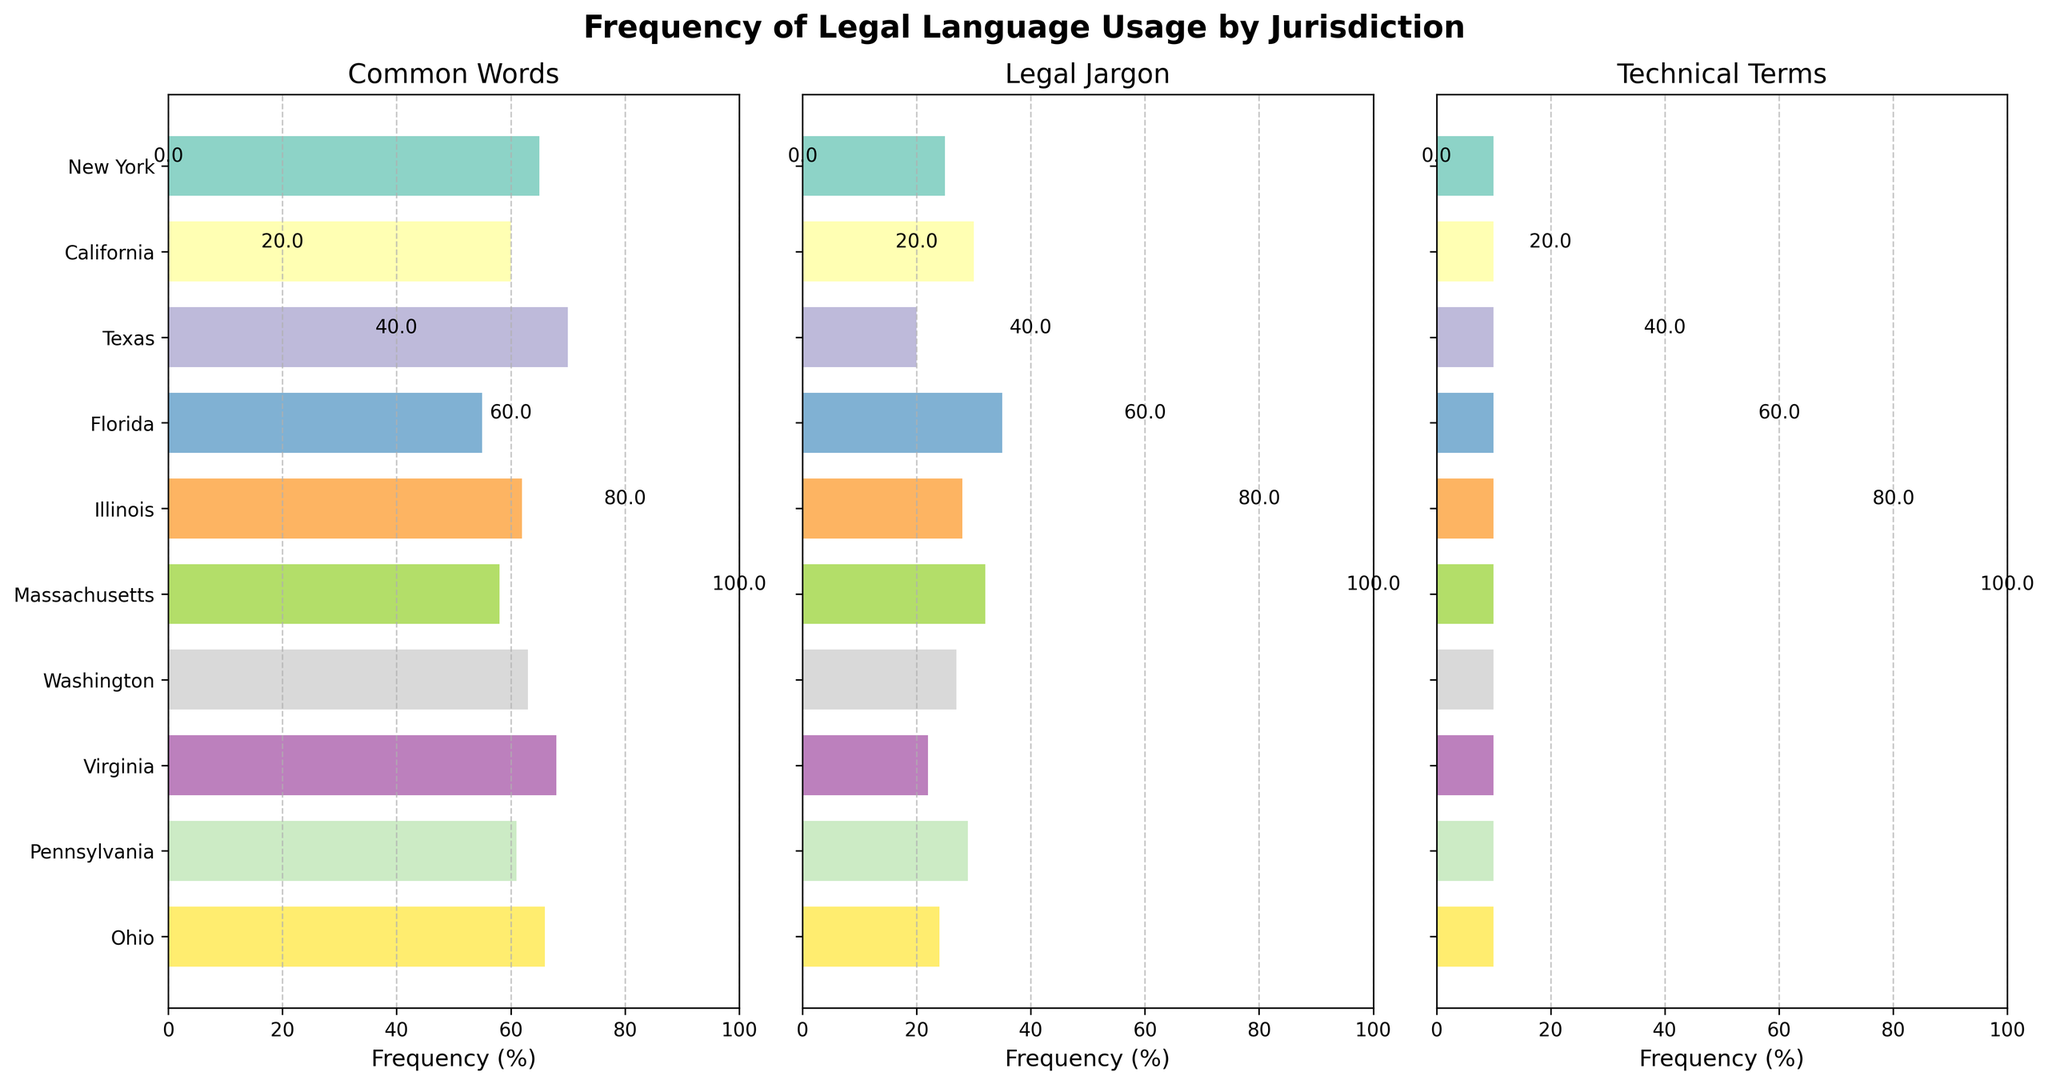Which jurisdiction has the highest frequency of common words? By looking at the "Common Words" subplot, we can see that Texas has the highest frequency bar for common words.
Answer: Texas Which jurisdiction has the lowest frequency of legal jargon? Observing the "Legal Jargon" subplot, we notice that Texas has the shortest bar, indicating it has the lowest frequency of legal jargon.
Answer: Texas What's the difference in frequency of legal jargon usage between California and Florida? California's bar in the "Legal Jargon" subplot is at 30%, while Florida's bar is at 35%. The difference is 35% - 30% = 5%.
Answer: 5% Which jurisdiction has an equal frequency of common words and legal jargon? By inspecting both the "Common Words" and "Legal Jargon" subplots, no jurisdiction has equal frequencies for both categories.
Answer: None How many jurisdictions have a technical terms frequency of 10%? From the "Technical Terms" subplot, all jurisdictions have bars at 10%, thus ten jurisdictions have a frequency of 10% for technical terms.
Answer: 10 What's the average frequency of common words across all jurisdictions? Sum the frequencies in the "Common Words" subplot: 65 + 60 + 70 + 55 + 62 + 58 + 63 + 68 + 61 + 66 = 628%. Divide by the number of jurisdictions, 628 / 10 = 62.8%.
Answer: 62.8% Compare the frequency of common words in New York and Ohio. Which jurisdiction uses them more frequently? The bar for New York in the "Common Words" subplot is at 65%, whereas for Ohio it is at 66%. Ohio uses common words more frequently.
Answer: Ohio Arrange the jurisdictions in descending order of their legal jargon usage. By examining the "Legal Jargon" subplot, the descending order is: Florida (35%), Massachusetts (32%), California (30%), Pennsylvania (29%), Illinois (28%), Washington (27%), Ohio (24%), Virginia (22%), New York (25%), Texas (20%).
Answer: Florida, Massachusetts, California, Pennsylvania, Illinois, Washington, Ohio, Virginia, New York, Texas What's the combined frequency of common words and legal jargon for Illinois? For Illinois, the "Common Words" frequency is 62%, and the "Legal Jargon" frequency is 28%. The combined frequency is 62% + 28% = 90%.
Answer: 90% Which jurisdictions have a higher frequency of legal jargon compared to common words? By looking at both the "Common Words" and "Legal Jargon" subplots, Florida is the only jurisdiction where the frequency of legal jargon (35%) is higher than the frequency of common words (55%).
Answer: Florida 